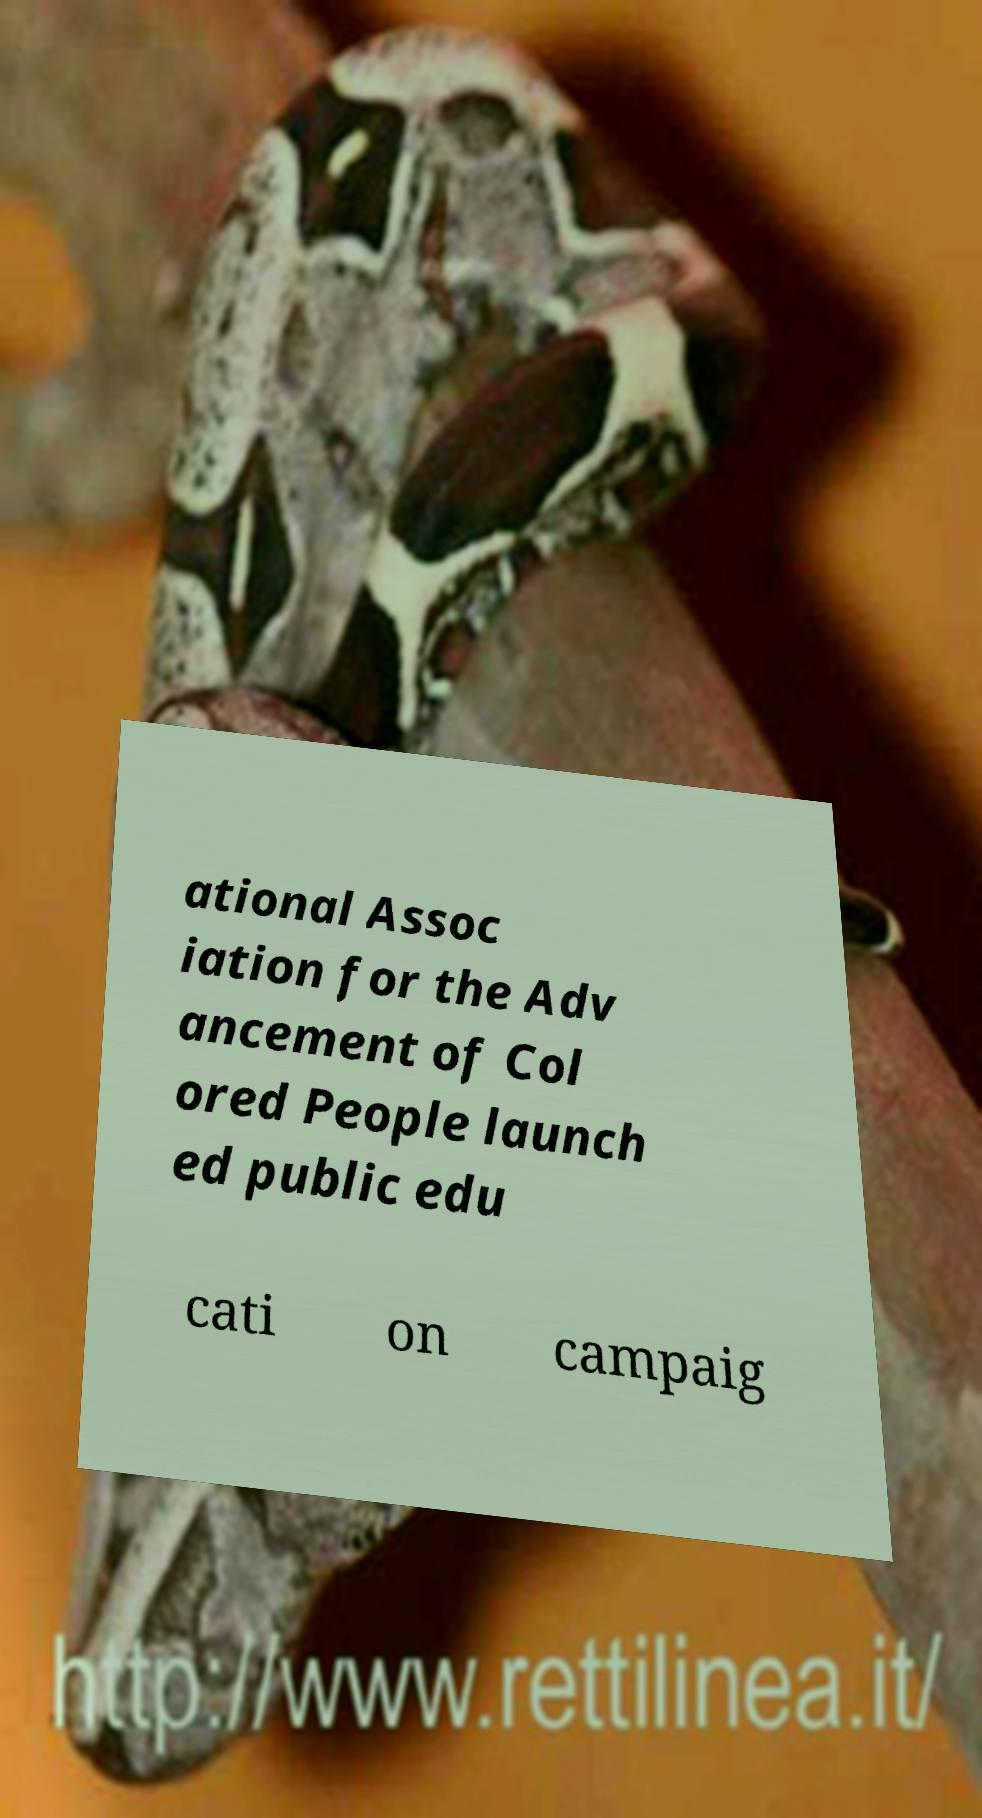Please identify and transcribe the text found in this image. ational Assoc iation for the Adv ancement of Col ored People launch ed public edu cati on campaig 